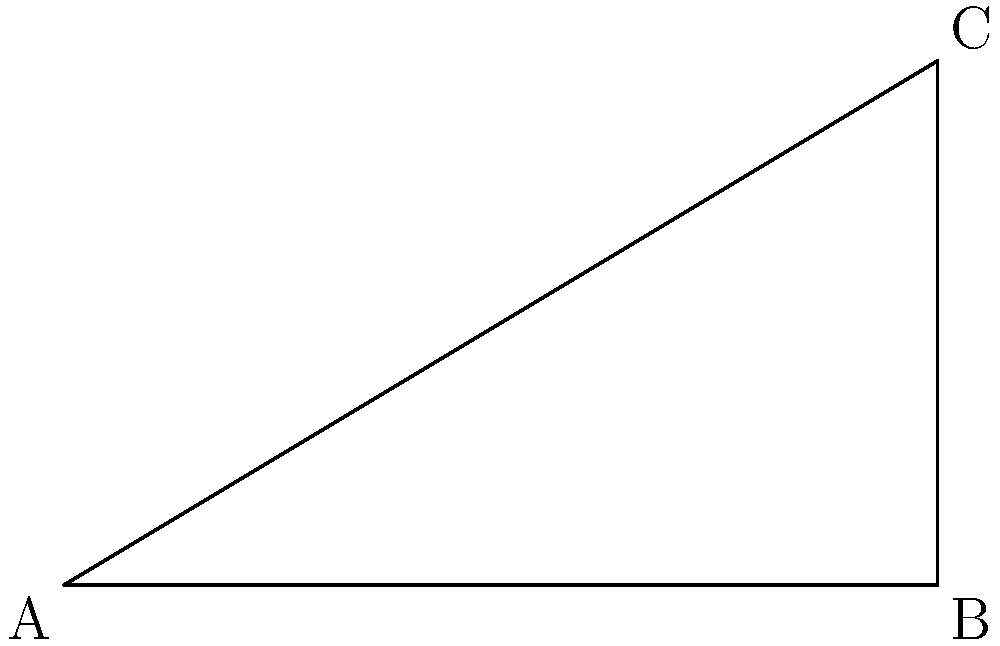As a writer arranging a display of classic novels, you want to create a sloped bookshelf that will keep the books from sliding off. If the shelf is 5 cm deep and you want the back edge to be 3 cm higher than the front edge, what angle $\theta$ should the shelf be tilted at to ensure the books stay in place? Let's approach this step-by-step using trigonometry:

1) We have a right-angled triangle where:
   - The base (adjacent to angle $\theta$) is 5 cm
   - The height (opposite to angle $\theta$) is 3 cm

2) To find the angle $\theta$, we can use the tangent function:

   $\tan \theta = \frac{\text{opposite}}{\text{adjacent}} = \frac{\text{height}}{\text{base}}$

3) Substituting our values:

   $\tan \theta = \frac{3}{5}$

4) To find $\theta$, we need to use the inverse tangent (arctan or $\tan^{-1}$):

   $\theta = \tan^{-1}(\frac{3}{5})$

5) Using a calculator or trigonometric tables:

   $\theta \approx 30.96^\circ$

Therefore, the shelf should be tilted at an angle of approximately 30.96° to keep the classic novels from sliding off.
Answer: $30.96^\circ$ 